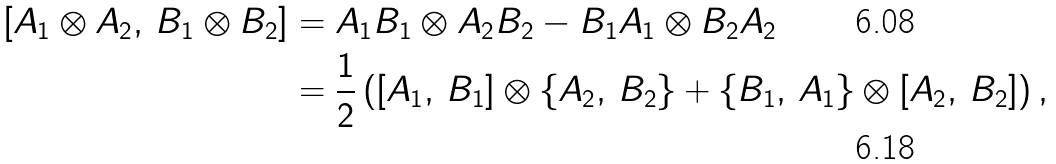<formula> <loc_0><loc_0><loc_500><loc_500>[ A _ { 1 } \otimes A _ { 2 } , \, B _ { 1 } \otimes B _ { 2 } ] & = A _ { 1 } B _ { 1 } \otimes A _ { 2 } B _ { 2 } - B _ { 1 } A _ { 1 } \otimes B _ { 2 } A _ { 2 } \\ & = \frac { 1 } { 2 } \left ( [ A _ { 1 } , \, B _ { 1 } ] \otimes \{ A _ { 2 } , \, B _ { 2 } \} + \{ B _ { 1 } , \, A _ { 1 } \} \otimes [ A _ { 2 } , \, B _ { 2 } ] \right ) ,</formula> 